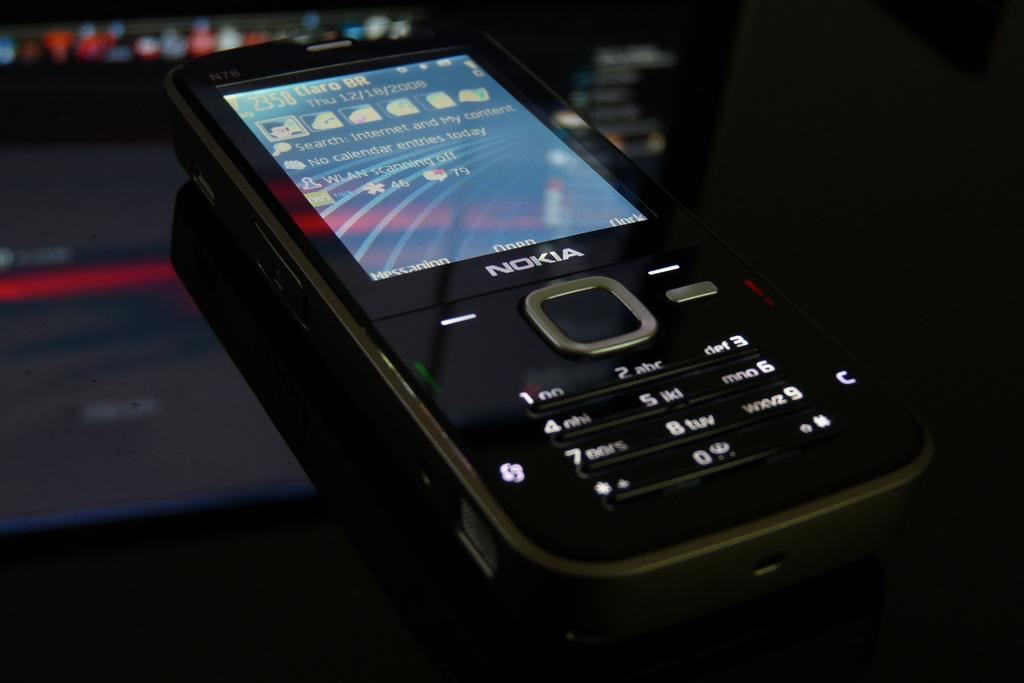<image>
Render a clear and concise summary of the photo. A rather old fashioned Nokia phone is sitting on a table. 